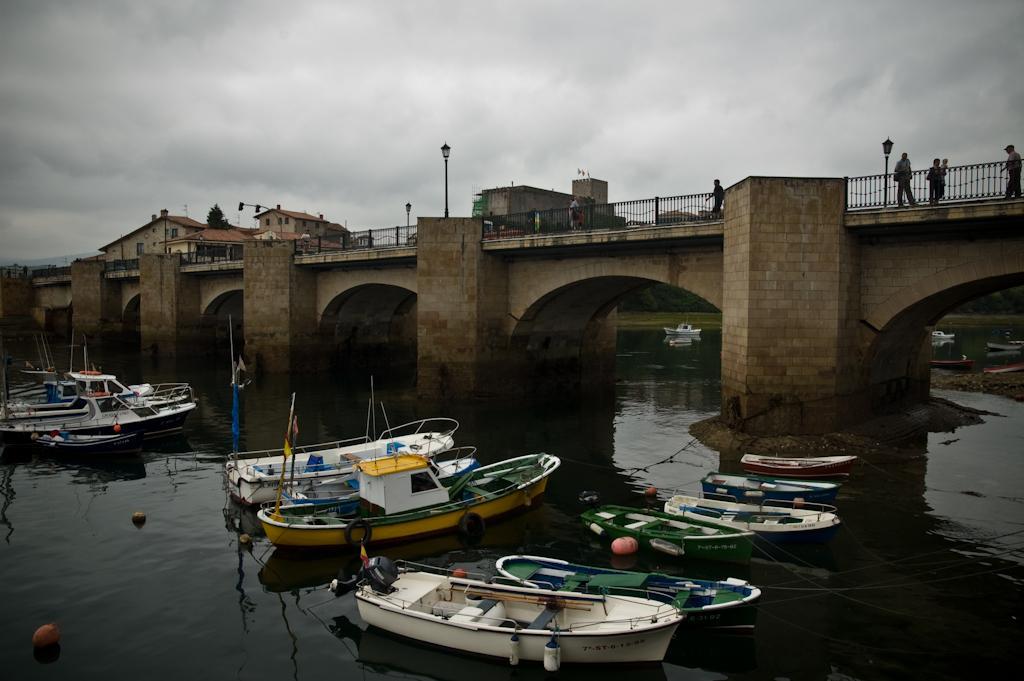Describe this image in one or two sentences. In this picture we can see many peoples walking on the bridge, besides them we can see fencing. On the bottom we can see many ships and boats on the water. On the left background we can see tree, street lights and buildings. On the top we can see sky and clouds. 